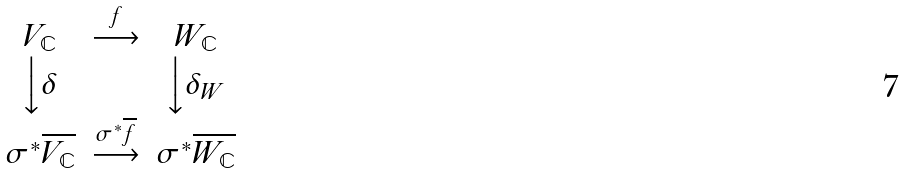Convert formula to latex. <formula><loc_0><loc_0><loc_500><loc_500>\begin{matrix} V _ { \mathbb { C } } & \stackrel { f } { \longrightarrow } & W _ { \mathbb { C } } \\ \Big \downarrow \delta & & \Big \downarrow \delta _ { W } \\ \sigma ^ { * } \overline { V _ { \mathbb { C } } } & \stackrel { \sigma ^ { * } \overline { f } } { \longrightarrow } & \sigma ^ { * } \overline { W _ { \mathbb { C } } } \end{matrix}</formula> 